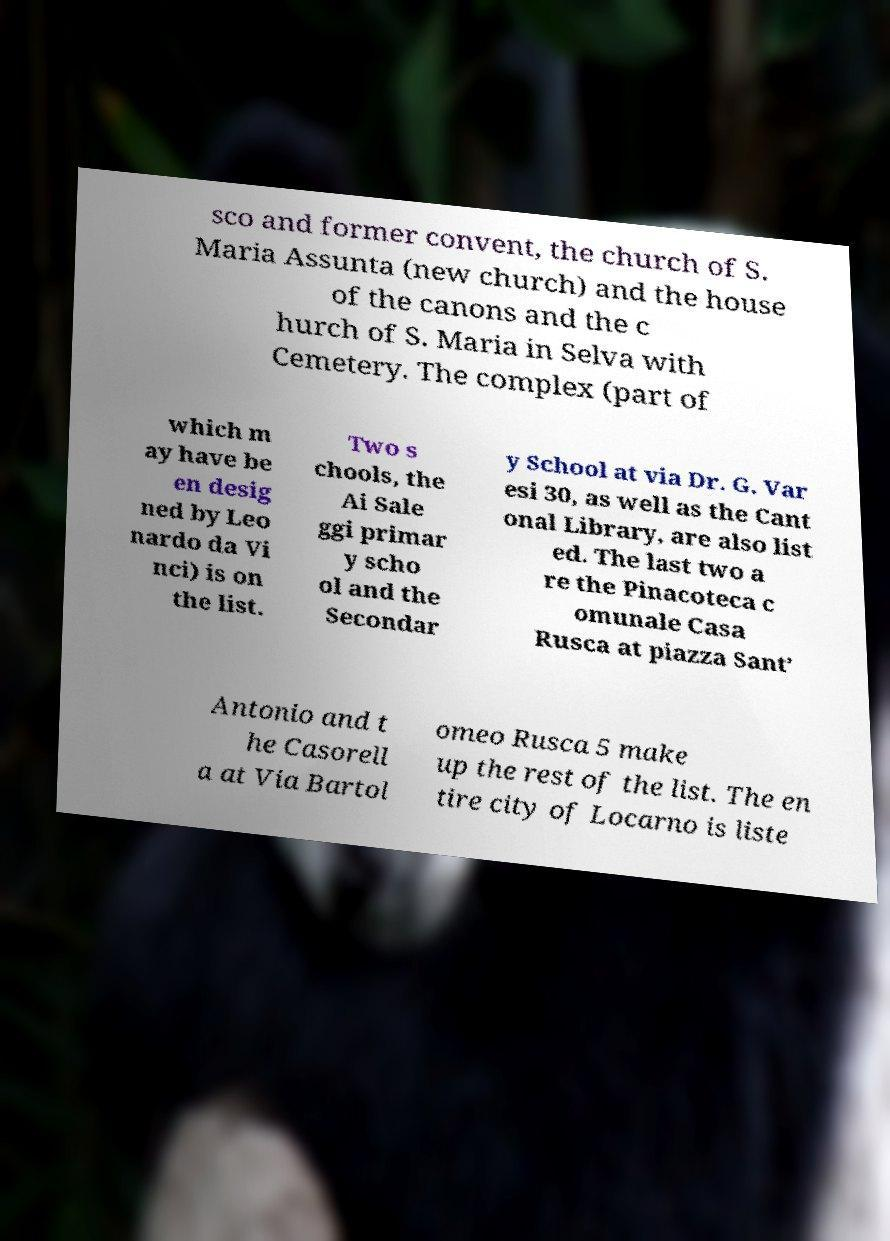I need the written content from this picture converted into text. Can you do that? sco and former convent, the church of S. Maria Assunta (new church) and the house of the canons and the c hurch of S. Maria in Selva with Cemetery. The complex (part of which m ay have be en desig ned by Leo nardo da Vi nci) is on the list. Two s chools, the Ai Sale ggi primar y scho ol and the Secondar y School at via Dr. G. Var esi 30, as well as the Cant onal Library, are also list ed. The last two a re the Pinacoteca c omunale Casa Rusca at piazza Sant’ Antonio and t he Casorell a at Via Bartol omeo Rusca 5 make up the rest of the list. The en tire city of Locarno is liste 